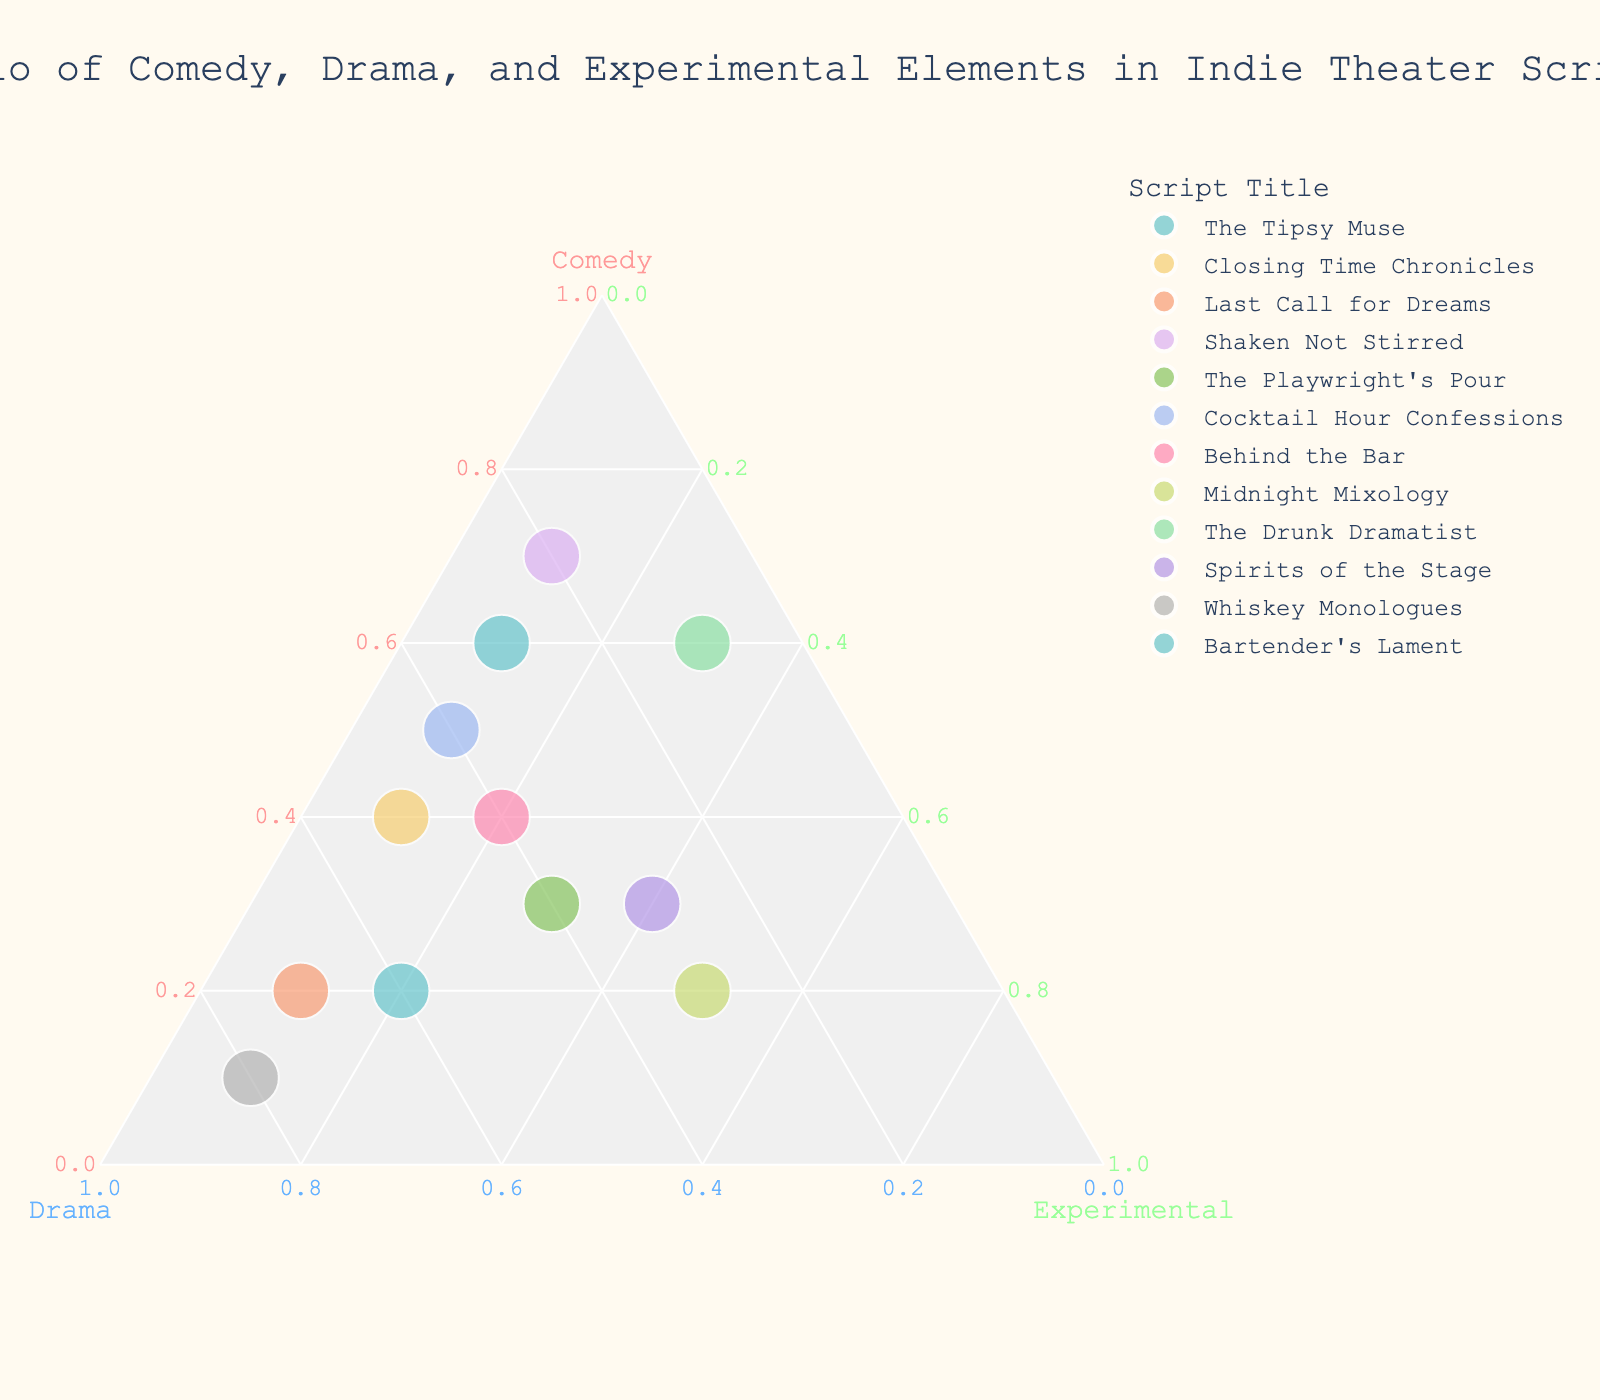what is the title of the plot? The title of a plot is usually found at the top of the figure, often formatted prominently. Here, it reads "Ratio of Comedy, Drama, and Experimental Elements in Indie Theater Scripts".
Answer: Ratio of Comedy, Drama, and Experimental Elements in Indie Theater Scripts how many scripts have been plotted? Each dot represents a script, and they can be counted to find the total number. Here, there are data points for 12 scripts on the plot.
Answer: 12 which script has the highest amount of comedy? To find the script with the highest comedy element, look for the data point positioned nearest to the vertex representing 1.0 on the Comedy axis. "Shaken Not Stirred" at 0.7 Comedy is not the highest since "The Tipsy Muse" hits the 0.6 mark.
Answer: The Tipsy Muse which script ranks highest in drama elements? Locate the data point closest to the Drama vertex. "Whiskey Monologues" situated at 0.8 on the Drama axis is the clear highest value.
Answer: Whiskey Monologues which script has an equal distribution of Drama and Experimental elements? Points with equal Drama and Experimental elements would lie along a line equidistant from both the Drama and Experimental vertices. "Spirits of the Stage" has 0.3 for both Drama and Experimental.
Answer: Spirits of the Stage how do you find the script with the closest balance between the three elements? A perfectly balanced script would be near the center of the plot. Scanning near the center, "The Playwright's Pour," having roughly equal splits of Comedy (0.3), Drama (0.4), and Experimental (0.3), fits closest.
Answer: The Playwright's Pour which scripts have the highest experimental elements? Identify points near the Experimental vertex. "Midnight Mixology" at 0.5 and "Spirits of the Stage" at 0.4 top the list for the highest Experimental values.
Answer: Midnight Mixology and Spirits of the Stage what is the average comedy value for all scripts? Sum all comedy values and divide by the number of scripts. This equates to (0.6 + 0.4 + 0.2 + 0.7 + 0.3 + 0.5 + 0.4 + 0.2 + 0.6 + 0.3 + 0.1 + 0.2) / 12 = 4.5 / 12 = 0.375.
Answer: 0.375 which script has the least amount of drama? Look for the point nearest to the origin on the Drama axis. "The Drunk Dramatist" at 0.1 Drama is tied with "Shaken Not Stirred," both having the least Drama.
Answer: The Drunk Dramatist and Shaken Not Stirred how many scripts have a comedy ratio greater than 0.4? Identify points with Comedy values exceeding 0.4. The scripts meeting this criterion are "The Tipsy Muse," "Shaken Not Stirred," "The Drunk Dramatist," "Cocktail Hour Confessions," and "Behind the Bar." This makes a total of 5.
Answer: 5 